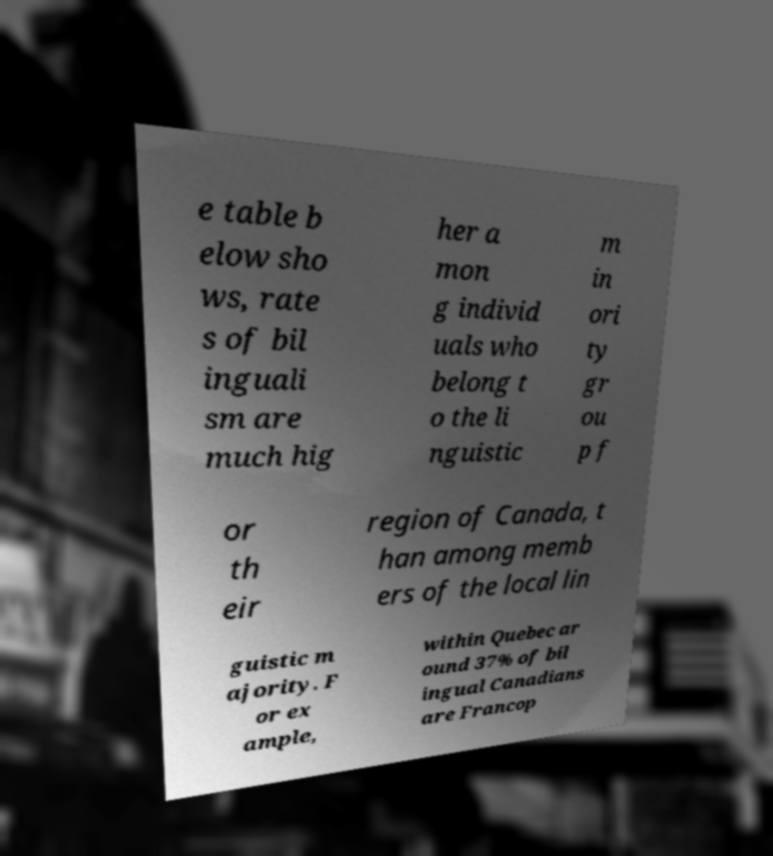I need the written content from this picture converted into text. Can you do that? e table b elow sho ws, rate s of bil inguali sm are much hig her a mon g individ uals who belong t o the li nguistic m in ori ty gr ou p f or th eir region of Canada, t han among memb ers of the local lin guistic m ajority. F or ex ample, within Quebec ar ound 37% of bil ingual Canadians are Francop 